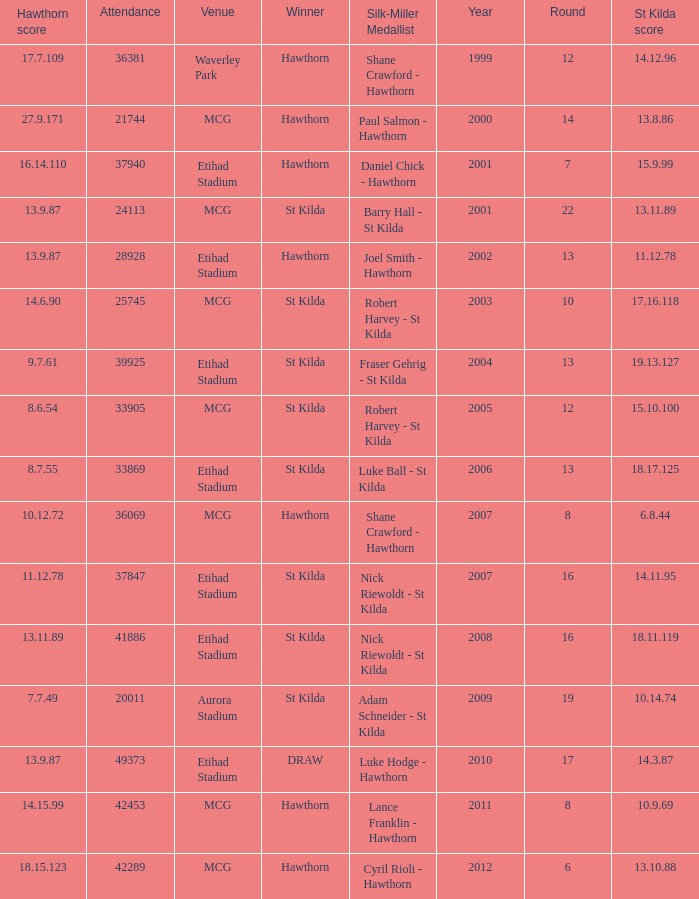What is the attendance when the hawthorn score is 18.15.123? 42289.0. Would you be able to parse every entry in this table? {'header': ['Hawthorn score', 'Attendance', 'Venue', 'Winner', 'Silk-Miller Medallist', 'Year', 'Round', 'St Kilda score'], 'rows': [['17.7.109', '36381', 'Waverley Park', 'Hawthorn', 'Shane Crawford - Hawthorn', '1999', '12', '14.12.96'], ['27.9.171', '21744', 'MCG', 'Hawthorn', 'Paul Salmon - Hawthorn', '2000', '14', '13.8.86'], ['16.14.110', '37940', 'Etihad Stadium', 'Hawthorn', 'Daniel Chick - Hawthorn', '2001', '7', '15.9.99'], ['13.9.87', '24113', 'MCG', 'St Kilda', 'Barry Hall - St Kilda', '2001', '22', '13.11.89'], ['13.9.87', '28928', 'Etihad Stadium', 'Hawthorn', 'Joel Smith - Hawthorn', '2002', '13', '11.12.78'], ['14.6.90', '25745', 'MCG', 'St Kilda', 'Robert Harvey - St Kilda', '2003', '10', '17.16.118'], ['9.7.61', '39925', 'Etihad Stadium', 'St Kilda', 'Fraser Gehrig - St Kilda', '2004', '13', '19.13.127'], ['8.6.54', '33905', 'MCG', 'St Kilda', 'Robert Harvey - St Kilda', '2005', '12', '15.10.100'], ['8.7.55', '33869', 'Etihad Stadium', 'St Kilda', 'Luke Ball - St Kilda', '2006', '13', '18.17.125'], ['10.12.72', '36069', 'MCG', 'Hawthorn', 'Shane Crawford - Hawthorn', '2007', '8', '6.8.44'], ['11.12.78', '37847', 'Etihad Stadium', 'St Kilda', 'Nick Riewoldt - St Kilda', '2007', '16', '14.11.95'], ['13.11.89', '41886', 'Etihad Stadium', 'St Kilda', 'Nick Riewoldt - St Kilda', '2008', '16', '18.11.119'], ['7.7.49', '20011', 'Aurora Stadium', 'St Kilda', 'Adam Schneider - St Kilda', '2009', '19', '10.14.74'], ['13.9.87', '49373', 'Etihad Stadium', 'DRAW', 'Luke Hodge - Hawthorn', '2010', '17', '14.3.87'], ['14.15.99', '42453', 'MCG', 'Hawthorn', 'Lance Franklin - Hawthorn', '2011', '8', '10.9.69'], ['18.15.123', '42289', 'MCG', 'Hawthorn', 'Cyril Rioli - Hawthorn', '2012', '6', '13.10.88']]} 